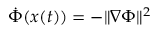Convert formula to latex. <formula><loc_0><loc_0><loc_500><loc_500>\dot { \Phi } ( { \boldsymbol x } ( t ) ) = - \| \nabla \Phi \| ^ { 2 }</formula> 